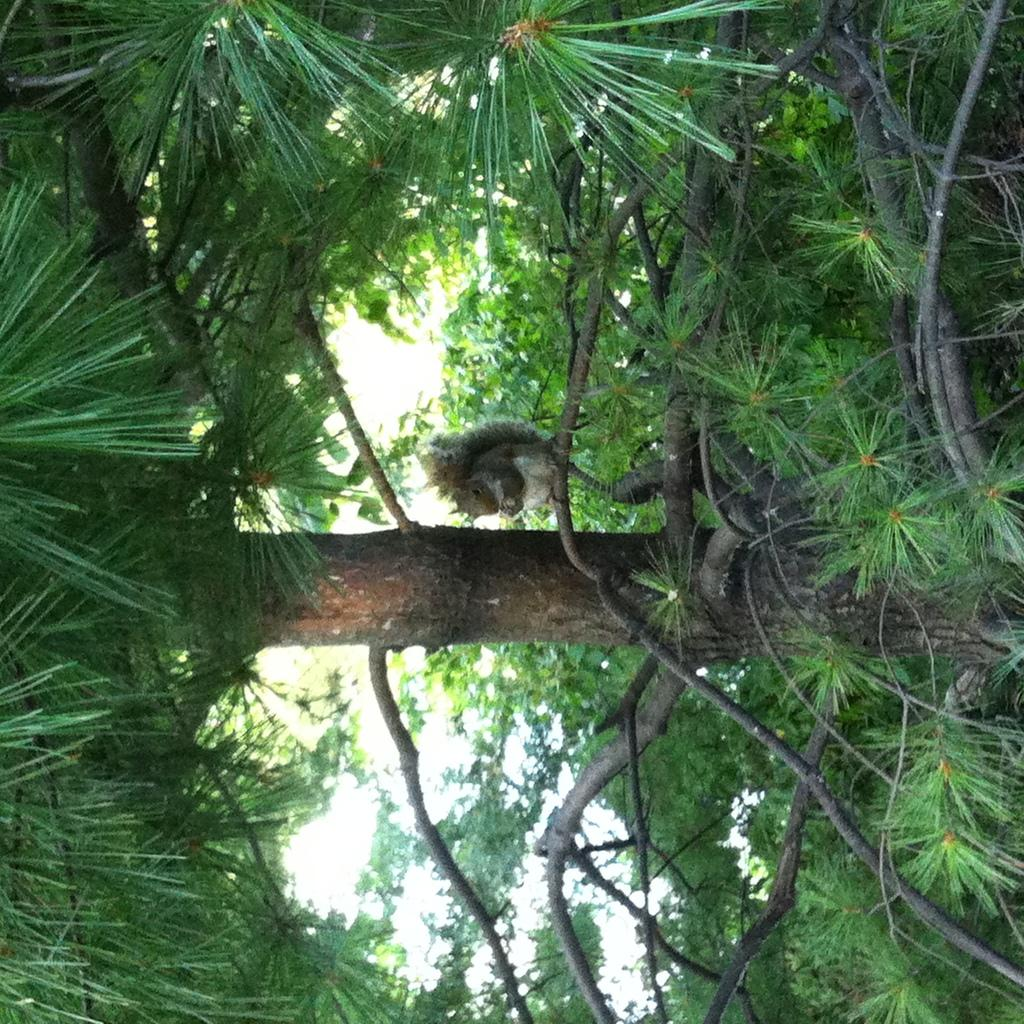What type of vegetation can be seen on the ground in the image? There are trees and plants on the ground in the image. What can be seen in the background of the image? The sky is visible in the background of the image. Can you describe the animal in the image? There is a squirrel on the branch of a tree in the middle of the image. How many balloons are tied to the squirrel in the image? There are no balloons present in the image; it features a squirrel on a tree branch. What type of yam is growing on the tree in the image? There are no yams present in the image; it features trees and plants, but not yams. 